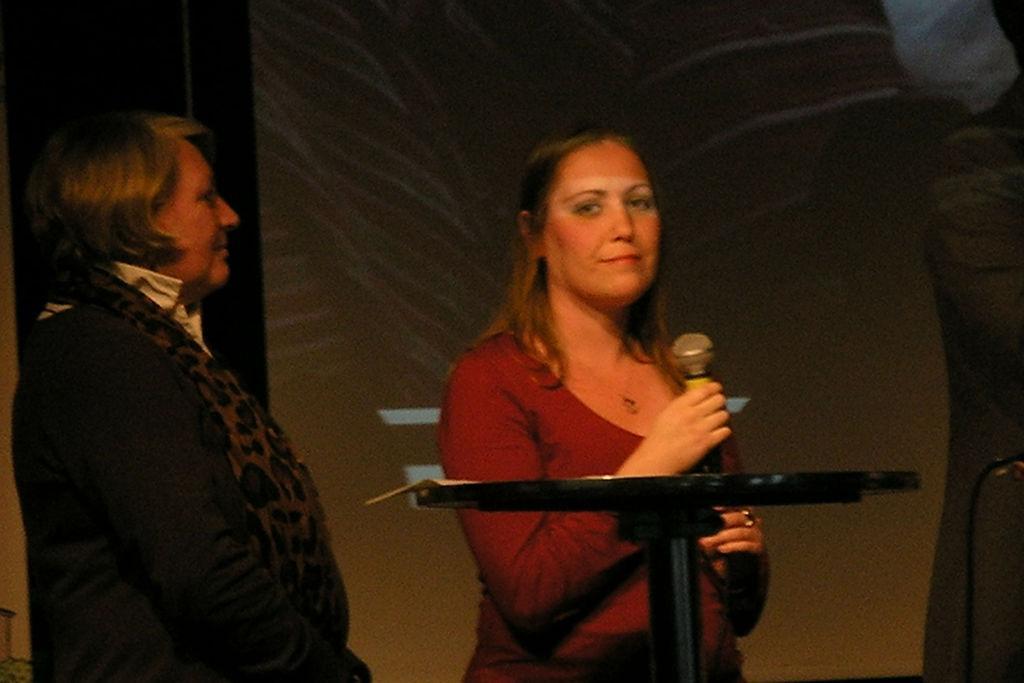How would you summarize this image in a sentence or two? In the left a woman is standing and in the right middle a woman is standing and holding a mike. In front of that a standing table is there. The background is of orange, white and grey in color. It looks as if the image is taken inside a stage during night time. 